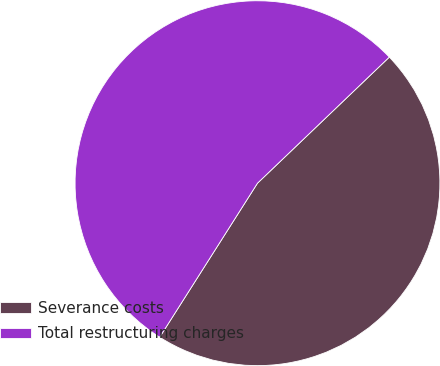<chart> <loc_0><loc_0><loc_500><loc_500><pie_chart><fcel>Severance costs<fcel>Total restructuring charges<nl><fcel>46.15%<fcel>53.85%<nl></chart> 